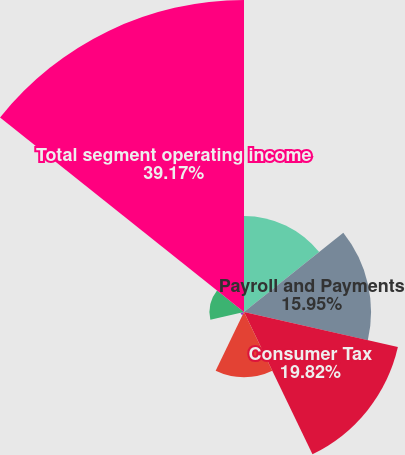Convert chart to OTSL. <chart><loc_0><loc_0><loc_500><loc_500><pie_chart><fcel>QuickBooks<fcel>Payroll and Payments<fcel>Consumer Tax<fcel>Accounting Professionals<fcel>Financial Institutions<fcel>Other Businesses<fcel>Total segment operating income<nl><fcel>12.07%<fcel>15.95%<fcel>19.82%<fcel>8.2%<fcel>0.46%<fcel>4.33%<fcel>39.18%<nl></chart> 